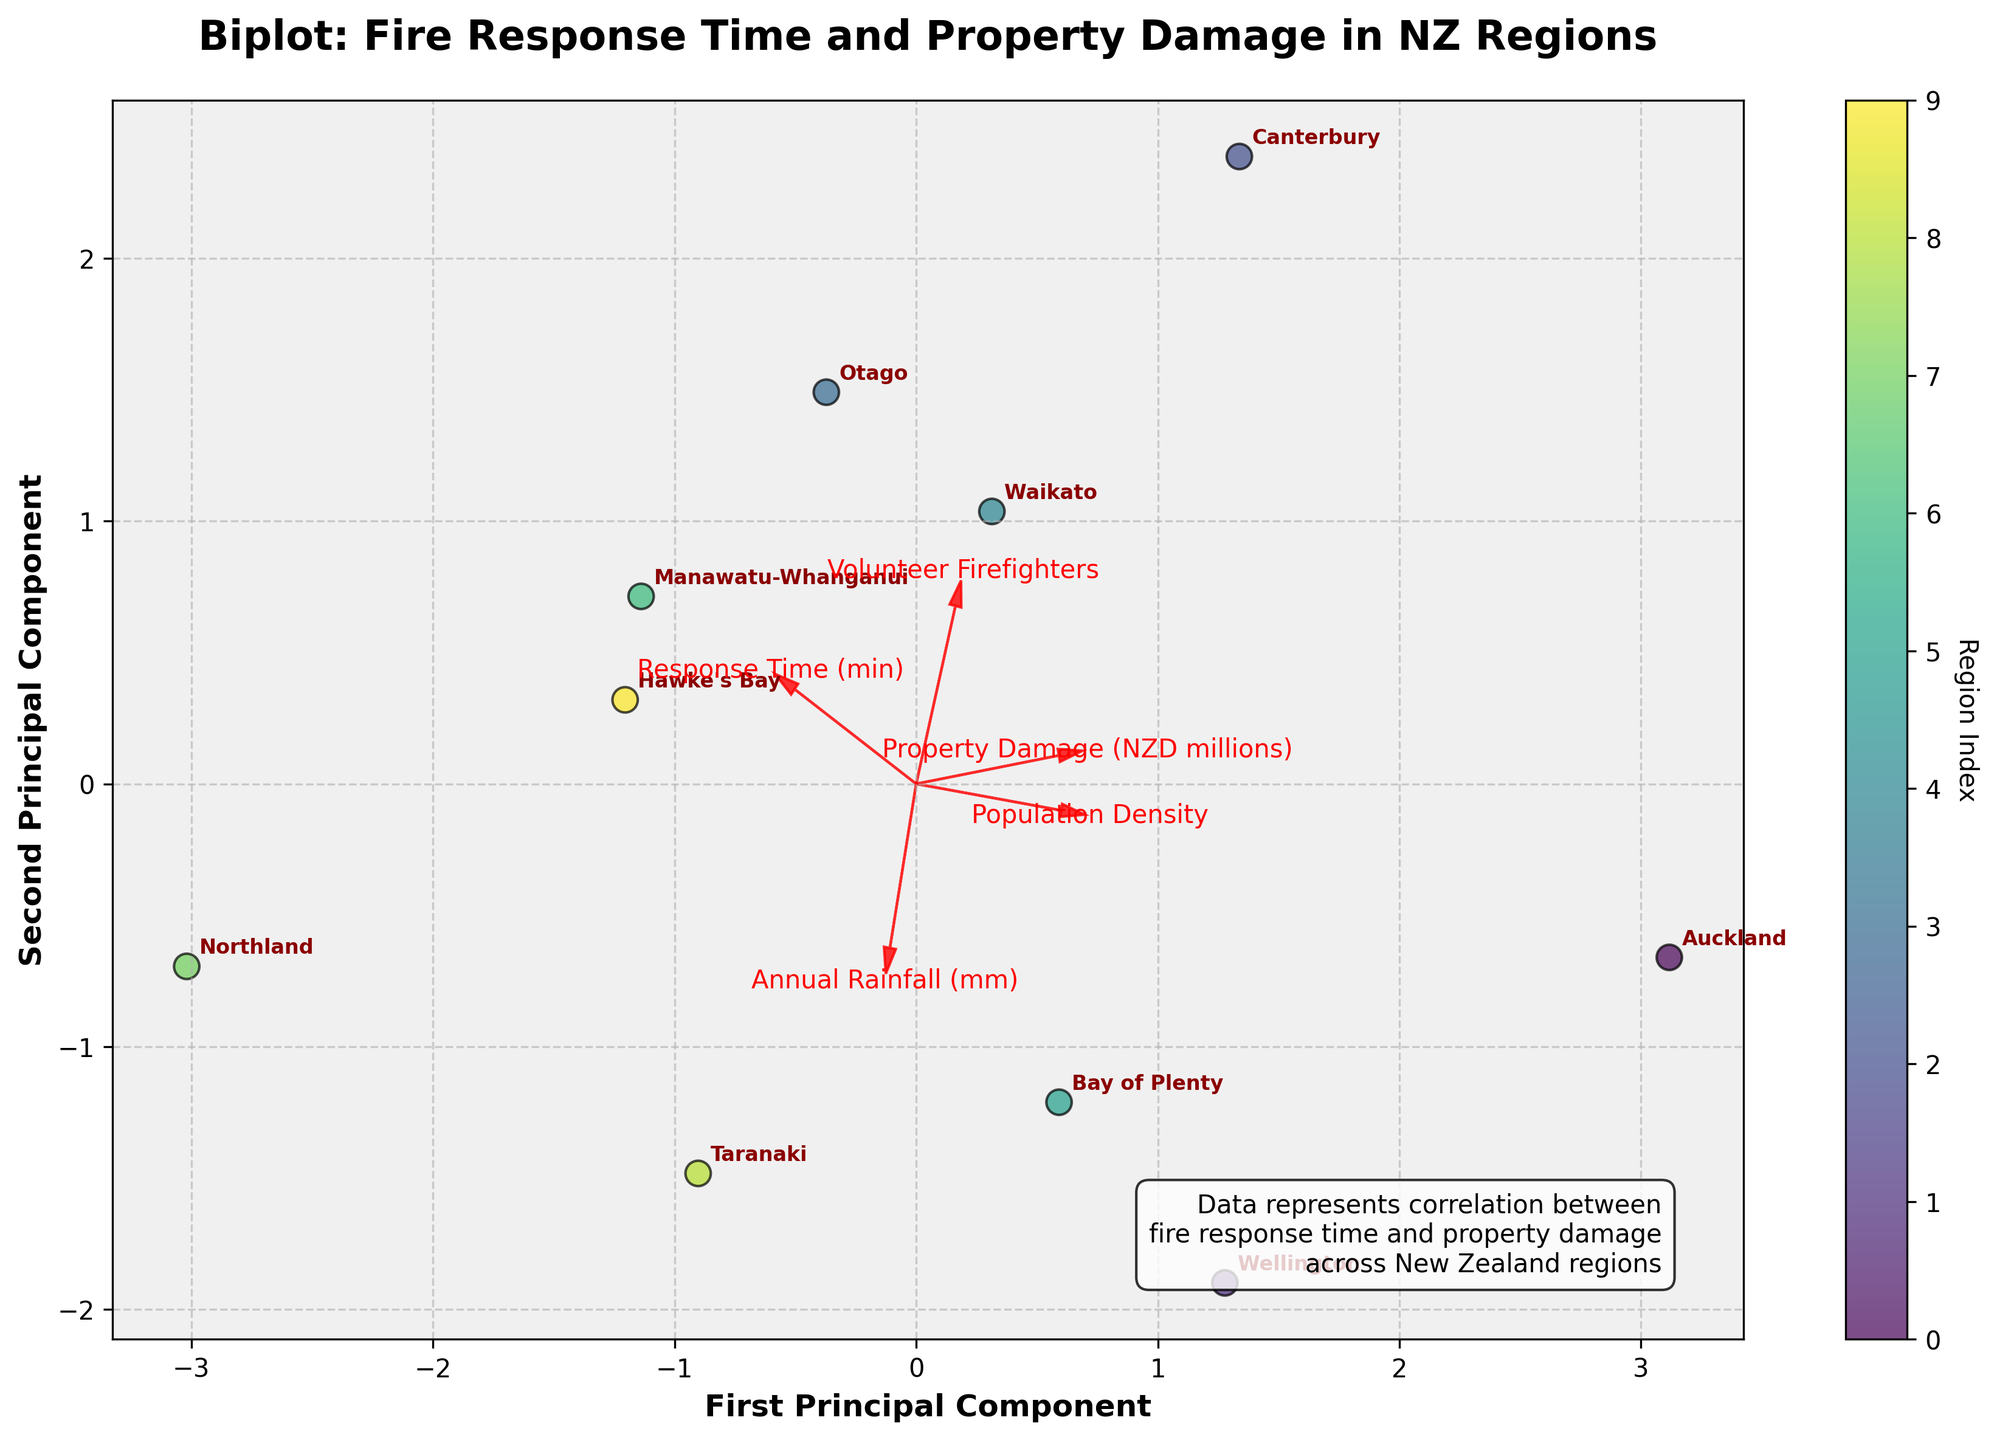Which region had the highest property damage? By looking at the figure, we identify the region that has the highest value along the property damage vector. Auckland has the highest value.
Answer: Auckland What is the correlation between response time and property damage? Observe the direction and alignment of the vectors for 'Response Time' and 'Property Damage'. Both vectors point in similar directions, suggesting a positive correlation.
Answer: Positive Which axis represents the first principal component? The axis labeled as 'First Principal Component' is the x-axis. The label is clearly indicated on the figure.
Answer: x-axis How many regions are represented in the figure? Count the number of data points or annotated region labels on the plot. There are 10 regions represented.
Answer: 10 Which feature vector points in the opposite direction to 'Annual Rainfall'? Look at the figure and check which vector is directly opposite to 'Annual Rainfall'. 'Property Damage' vector points in the opposite direction.
Answer: Property Damage Which region has the response time closest to the median value? Identify the regions with response times and determine the middle value when arranging the times in ascending order. The median value is the average of Canterbury and Waikato response times, which is around 8.7 minutes. 'Canterbury' is closest to this value.
Answer: Canterbury Which region has the smallest population density? Identify the region that is at the extremity of the 'Population Density' vector pointing towards the lower values. Northland has the smallest population density.
Answer: Northland Which regions have a response time greater than 9 minutes? Look at the points located on the positive side of the 'Response Time' vector. Otago, Waikato, Manawatu-Whanganui, and Northland have response times greater than 9 minutes.
Answer: Otago, Waikato, Manawatu-Whanganui, Northland What do the vector arrows represent in the plot? The vector arrows represent the direction and magnitude of each feature. They help in understanding how each feature is correlated with the principal components.
Answer: Direction and magnitude of features Does the principal component analysis (PCA) reduce the data dimensions, and what can we infer from this? PCA reduces the data to two principal components, represented by the x and y axes. This reduction simplifies the analysis and visualization of the multivariate data, helping us identify patterns and correlations among the features and regions.
Answer: Yes, PCA reduces dimensions and simplifies analysis and visualization 